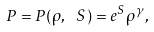<formula> <loc_0><loc_0><loc_500><loc_500>P = P ( \rho , \ S ) = e ^ { S } \rho ^ { \gamma } ,</formula> 